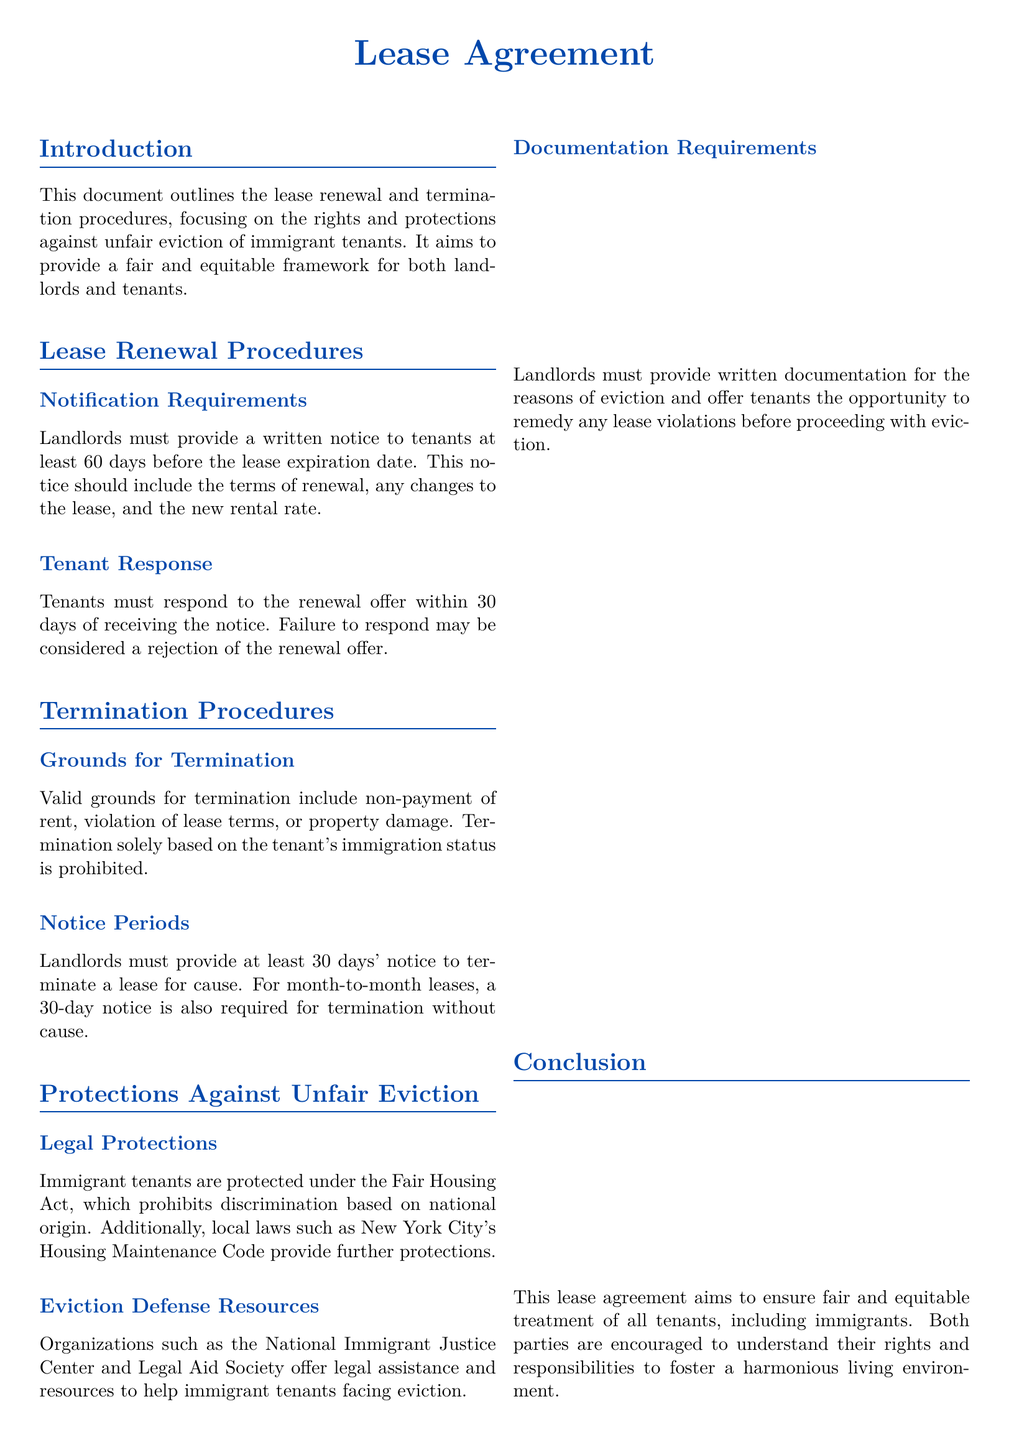What is the lease expiration notification period? The lease expiration notification period is mentioned under the lease renewal procedures and is at least 60 days.
Answer: 60 days How long do tenants have to respond to a renewal offer? The document specifies that tenants must respond to the renewal offer within 30 days of receiving the notice.
Answer: 30 days What grounds for termination are prohibited? The document outlines grounds for termination and states that termination solely based on the tenant's immigration status is prohibited.
Answer: Immigration status What must landlords provide for eviction reasons? The lease agreement states that landlords must provide written documentation for the reasons of eviction.
Answer: Written documentation Which act protects immigrant tenants against discrimination? The document cites the Fair Housing Act, which prohibits discrimination based on national origin.
Answer: Fair Housing Act How many days' notice is required for lease termination? The lease agreement requires at least 30 days' notice to terminate a lease for cause or without cause.
Answer: 30 days What organizations offer assistance to tenants facing eviction? The document mentions organizations such as the National Immigrant Justice Center and Legal Aid Society offering assistance.
Answer: National Immigrant Justice Center, Legal Aid Society What is included in the landlord's written notification for lease renewal? The notification must include the terms of renewal, any changes to the lease, and the new rental rate.
Answer: Terms of renewal, changes, new rental rate What is the purpose of this lease agreement? The purpose is to ensure fair and equitable treatment of all tenants, including immigrants.
Answer: Fair and equitable treatment 